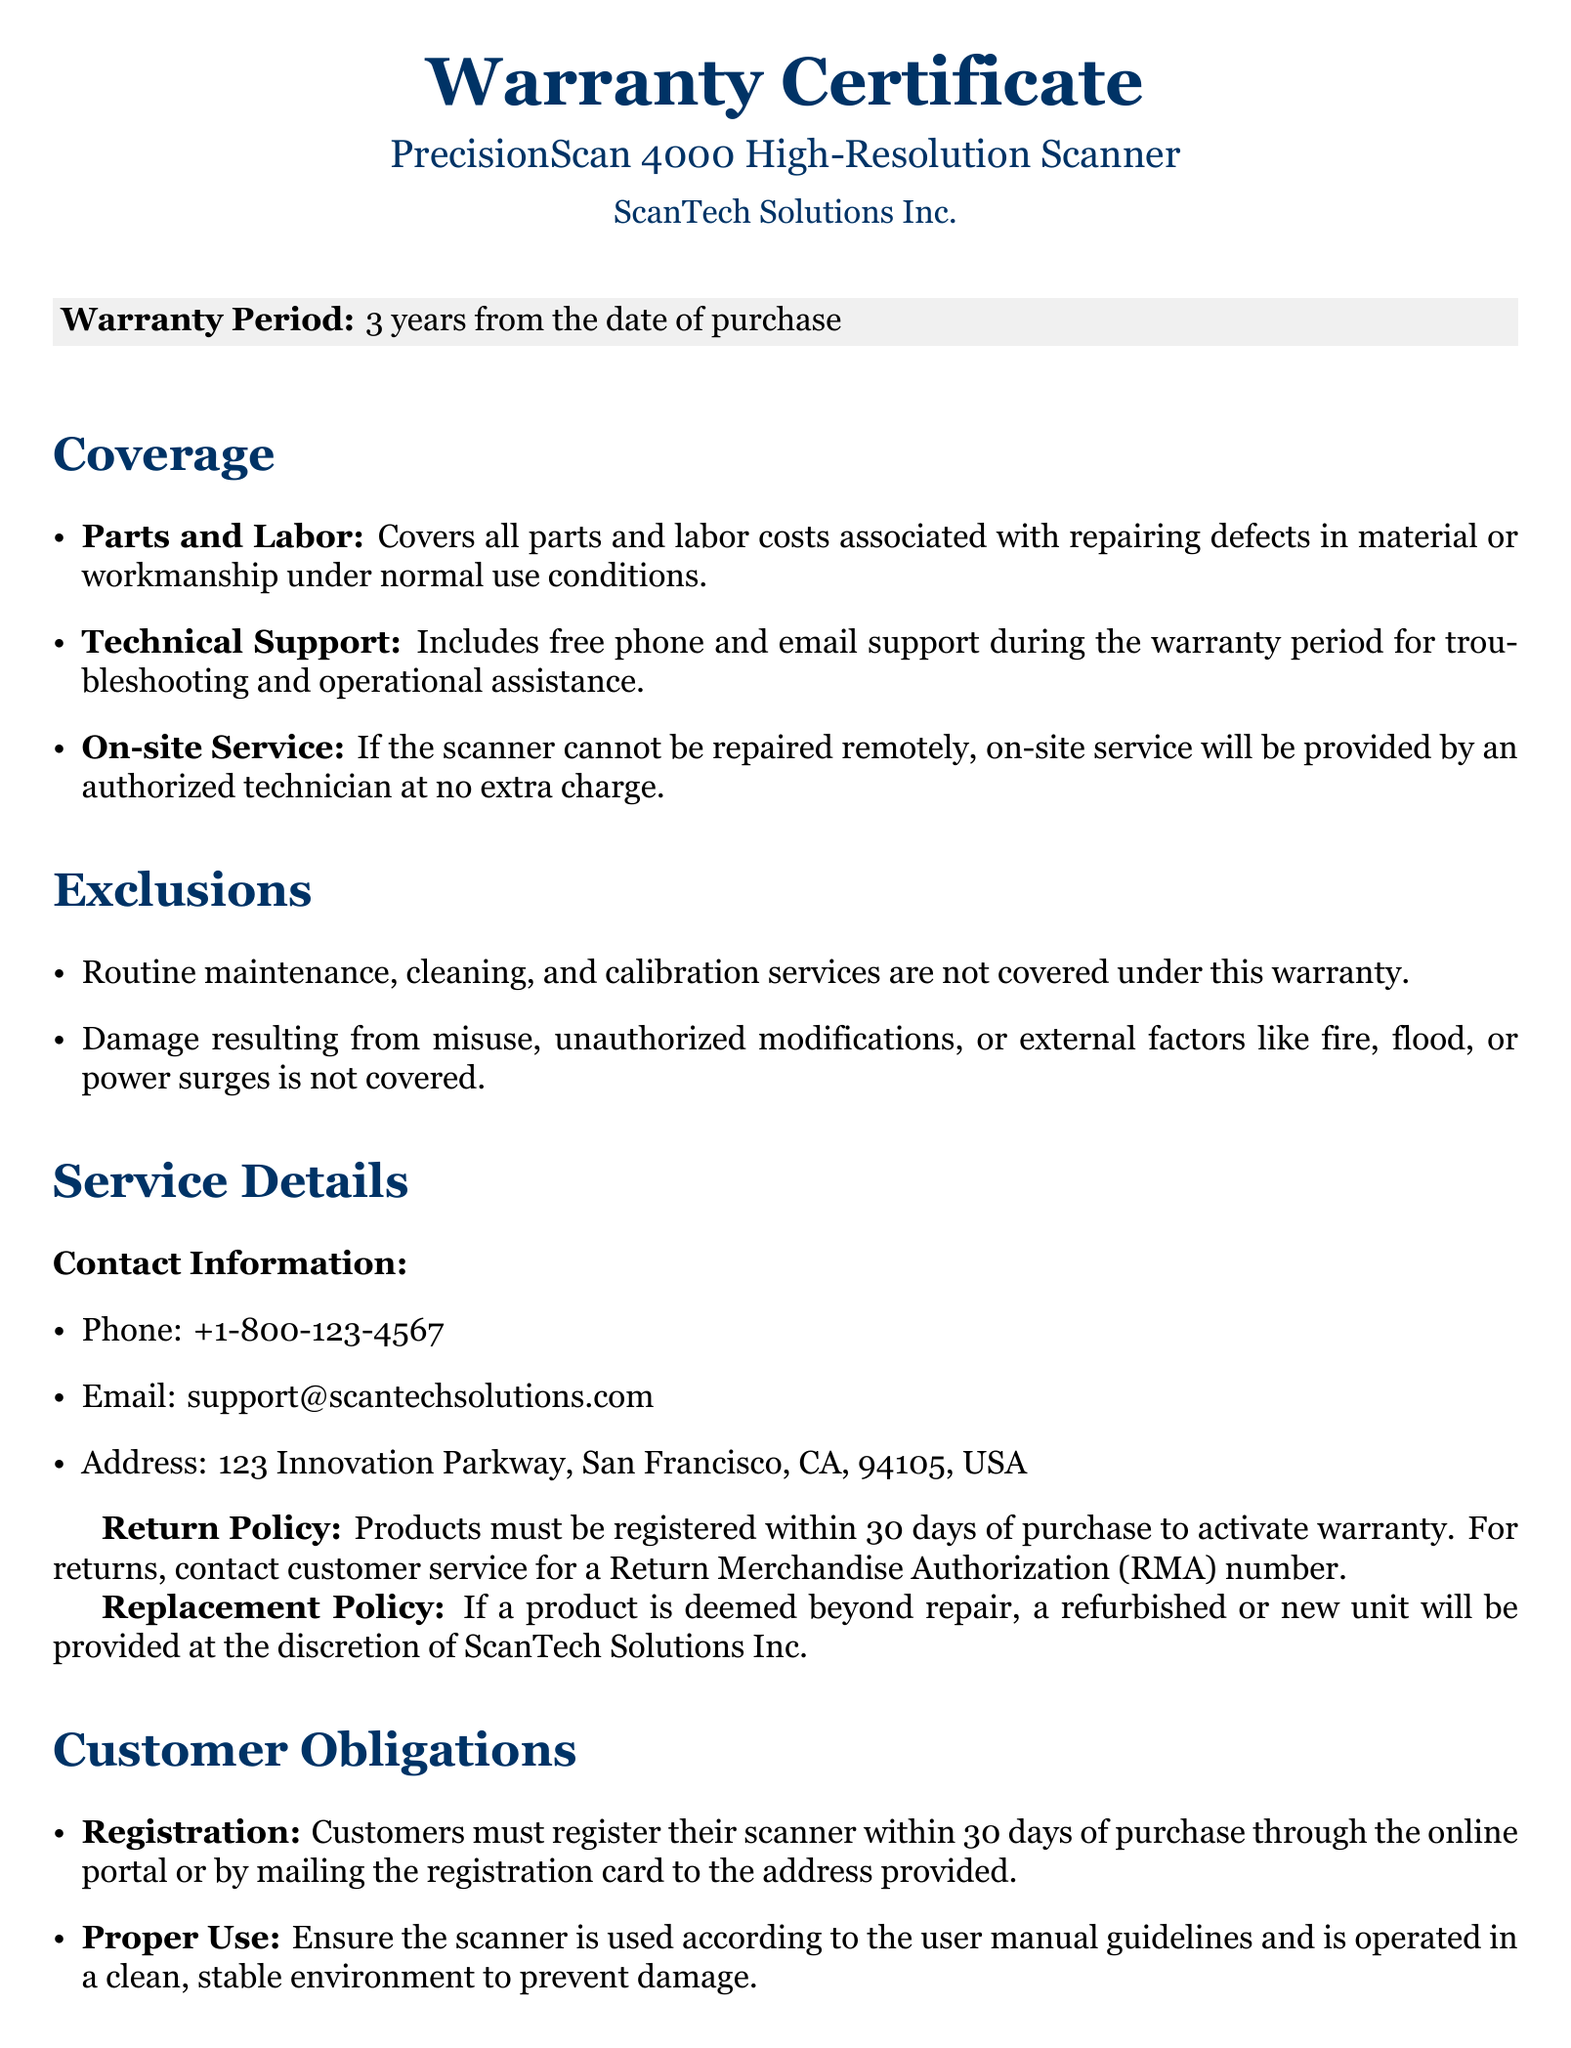What is the warranty period? The warranty period is specified in the document as lasting for three years from the date of purchase.
Answer: 3 years What services are covered under the warranty? The document lists parts and labor, technical support, and on-site service as covered services.
Answer: Parts and Labor, Technical Support, On-site Service What is not covered under this warranty? The document specifies that routine maintenance, misuse, and damage from external factors are exclusions.
Answer: Routine maintenance, misuse, damage from external factors What is the contact phone number for support? The document provides a specific phone number for technical support.
Answer: +1-800-123-4567 How long do customers have to register their scanner? The document states that customers must register within a certain timeframe after purchase.
Answer: 30 days What action must be taken for product returns? The document mentions that a customer should contact customer service for a specific authorization number for returns.
Answer: Return Merchandise Authorization (RMA) number What should customers ensure regarding the use of the scanner? The document highlights that customers must use the scanner according to the user manual guidelines and in a stable environment.
Answer: Proper use according to guidelines What happens if a product is deemed beyond repair? The document notes that a refurbished or new unit will be provided at the discretion of the company if the product cannot be repaired.
Answer: Refurbished or new unit What is the legal governing body for this warranty? The document mentions the legal context that governs the warranty's terms and conditions.
Answer: State of California 